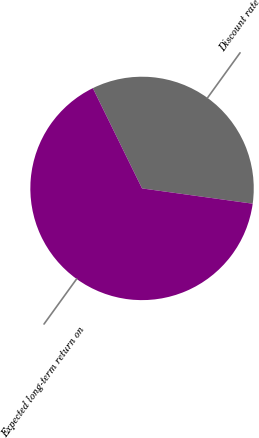Convert chart to OTSL. <chart><loc_0><loc_0><loc_500><loc_500><pie_chart><fcel>Discount rate<fcel>Expected long-term return on<nl><fcel>34.45%<fcel>65.55%<nl></chart> 